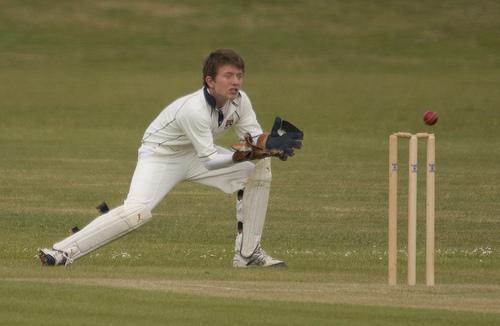How many people are in this picture?
Give a very brief answer. 1. How many people are visible?
Give a very brief answer. 1. 